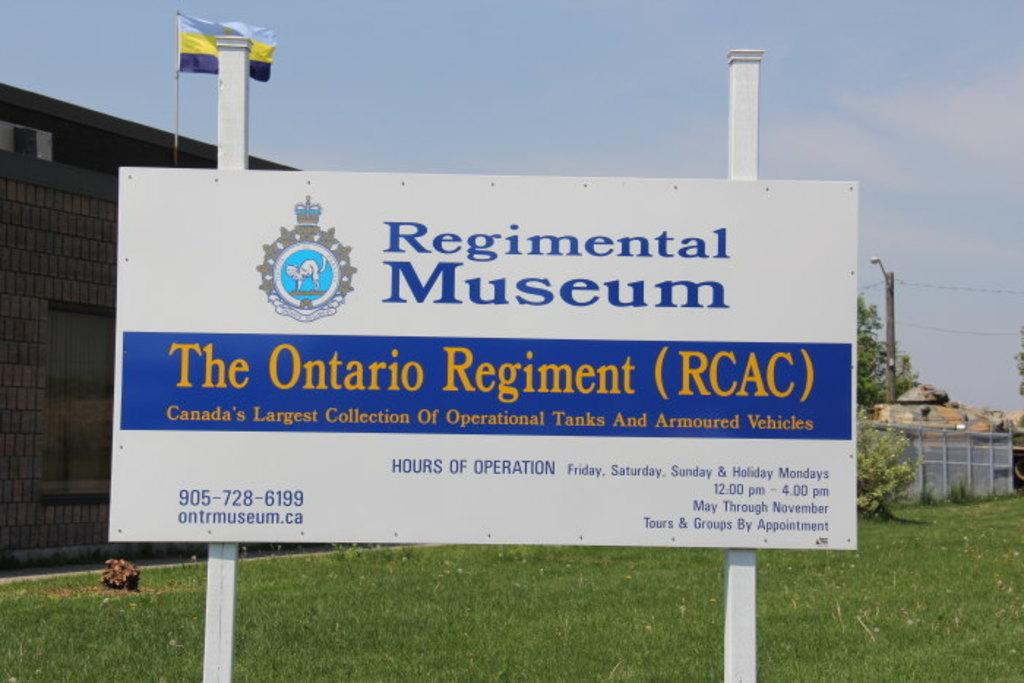<image>
Write a terse but informative summary of the picture. A large white sign in front of a building says Regimental Museum. 